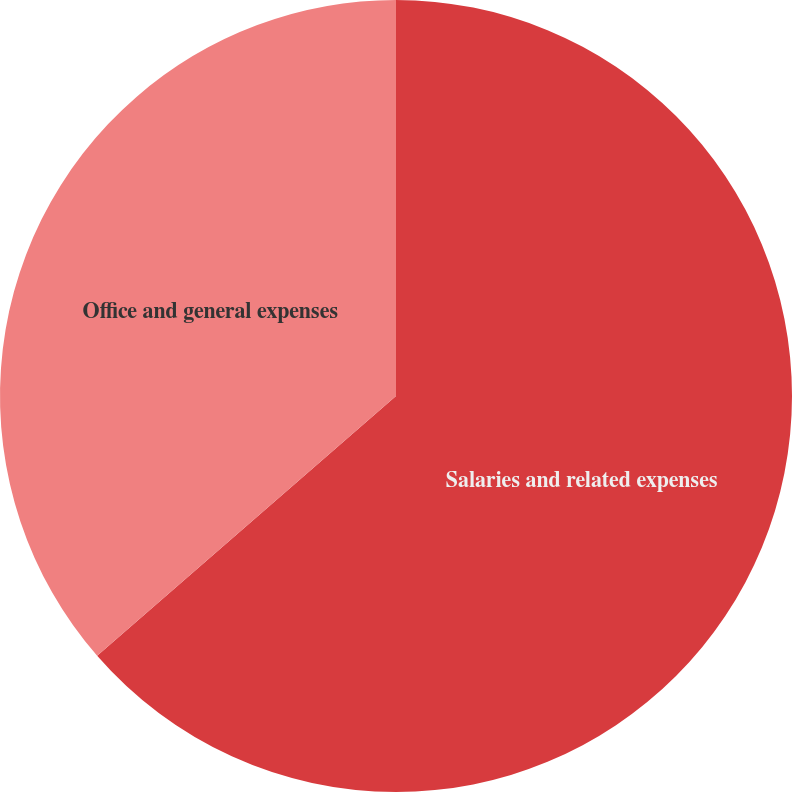Convert chart to OTSL. <chart><loc_0><loc_0><loc_500><loc_500><pie_chart><fcel>Salaries and related expenses<fcel>Office and general expenses<nl><fcel>63.61%<fcel>36.39%<nl></chart> 